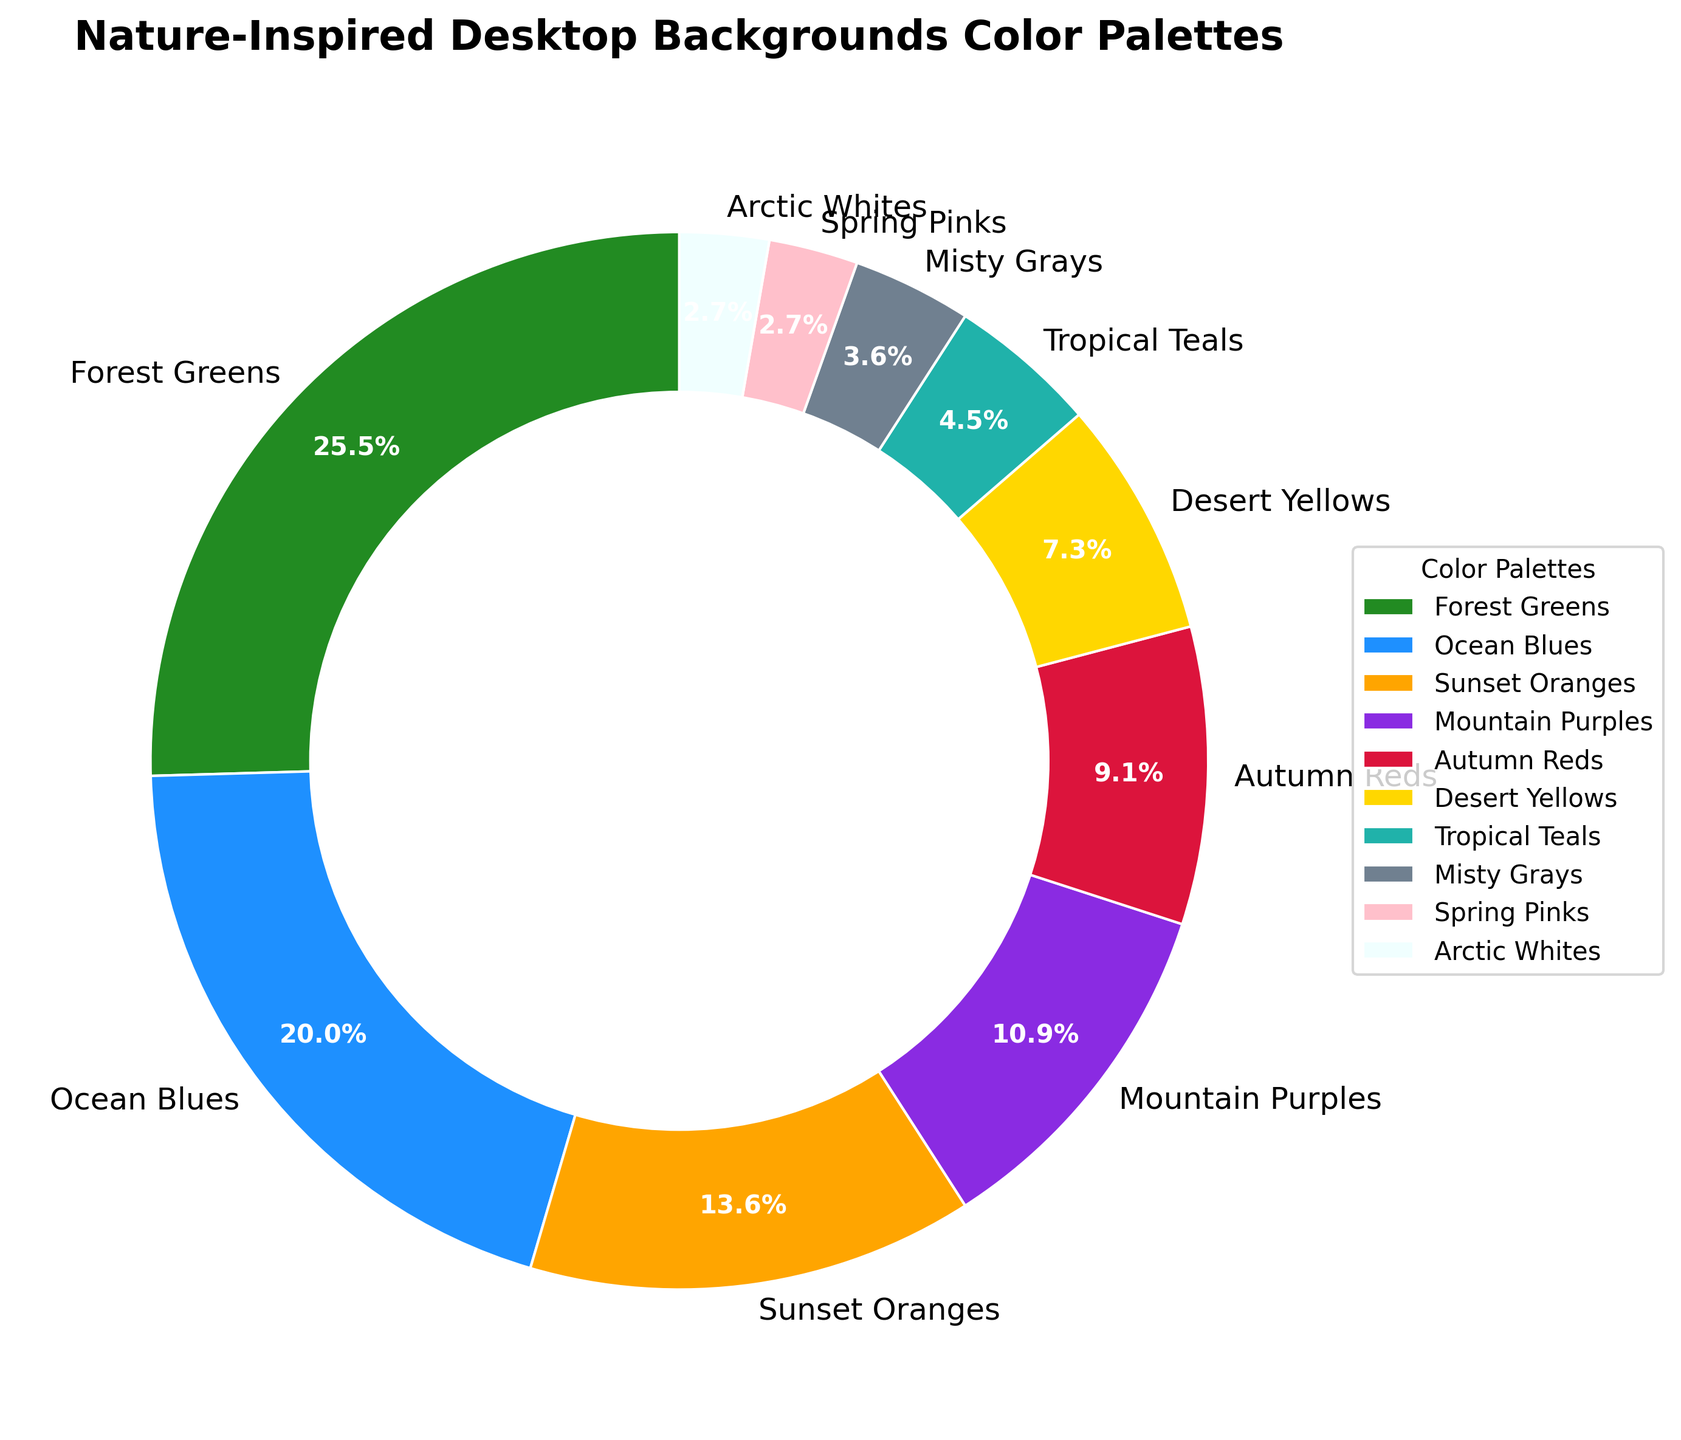Which color palette is used the most in nature-inspired desktop backgrounds? The pie chart shows that "Forest Greens" occupies the largest segment, indicating that it is used the most.
Answer: Forest Greens How much more popular is "Forest Greens" compared to "Tropical Teals"? Look at the percentages for "Forest Greens" and "Tropical Teals." Subtract the smaller percentage (5% for Tropical Teals) from the larger one (28% for Forest Greens). 28 - 5 = 23.
Answer: 23% Which two color palettes are used the least and what is their combined percentage? Identify the two smallest segments from the chart, "Spring Pinks" and "Arctic Whites," both at 3%. Add their percentages: 3 + 3 = 6.
Answer: Spring Pinks and Arctic Whites; 6% What is the total percentage of blue-themed palettes ("Ocean Blues" and "Tropical Teals")? Find the percentages of "Ocean Blues" and "Tropical Teals" from the chart. Add them together: 22% + 5%.
Answer: 27% Are there more backgrounds using "Mountain Purples" or "Sunset Oranges"? Compare the percentages of "Mountain Purples" (12%) and "Sunset Oranges" (15%) shown on the chart. 15% is greater than 12%.
Answer: Sunset Oranges Which is more popular: "Desert Yellows" or "Autumn Reds"? Observe the percentages: "Desert Yellows" at 8% and "Autumn Reds" at 10%. 10% is greater than 8%.
Answer: Autumn Reds How does the popularity of "Misty Grays" compare to "Spring Pinks"? Check the chart for percentages of "Misty Grays" (4%) and "Spring Pinks" (3%). 4% is greater than 3%.
Answer: Misty Grays Rank the color palettes in decreasing order of their usage. Read off all the color palette names from the largest to smallest percentage.
Answer: Forest Greens, Ocean Blues, Sunset Oranges, Mountain Purples, Autumn Reds, Desert Yellows, Tropical Teals, Misty Grays, Spring Pinks, Arctic Whites If "Arctic Whites" share increased by 2%, which other category would it match in usage? "Arctic Whites" currently have 3%. Adding 2% makes it 5%, which matches "Tropical Teals" in the chart.
Answer: Tropical Teals What is the difference in percentage usage between the most and least popular color palettes? Find the most popular ("Forest Greens" at 28%) and least popular ones ("Spring Pinks" and "Arctic Whites" both at 3%) and subtract: 28% - 3%.
Answer: 25% 